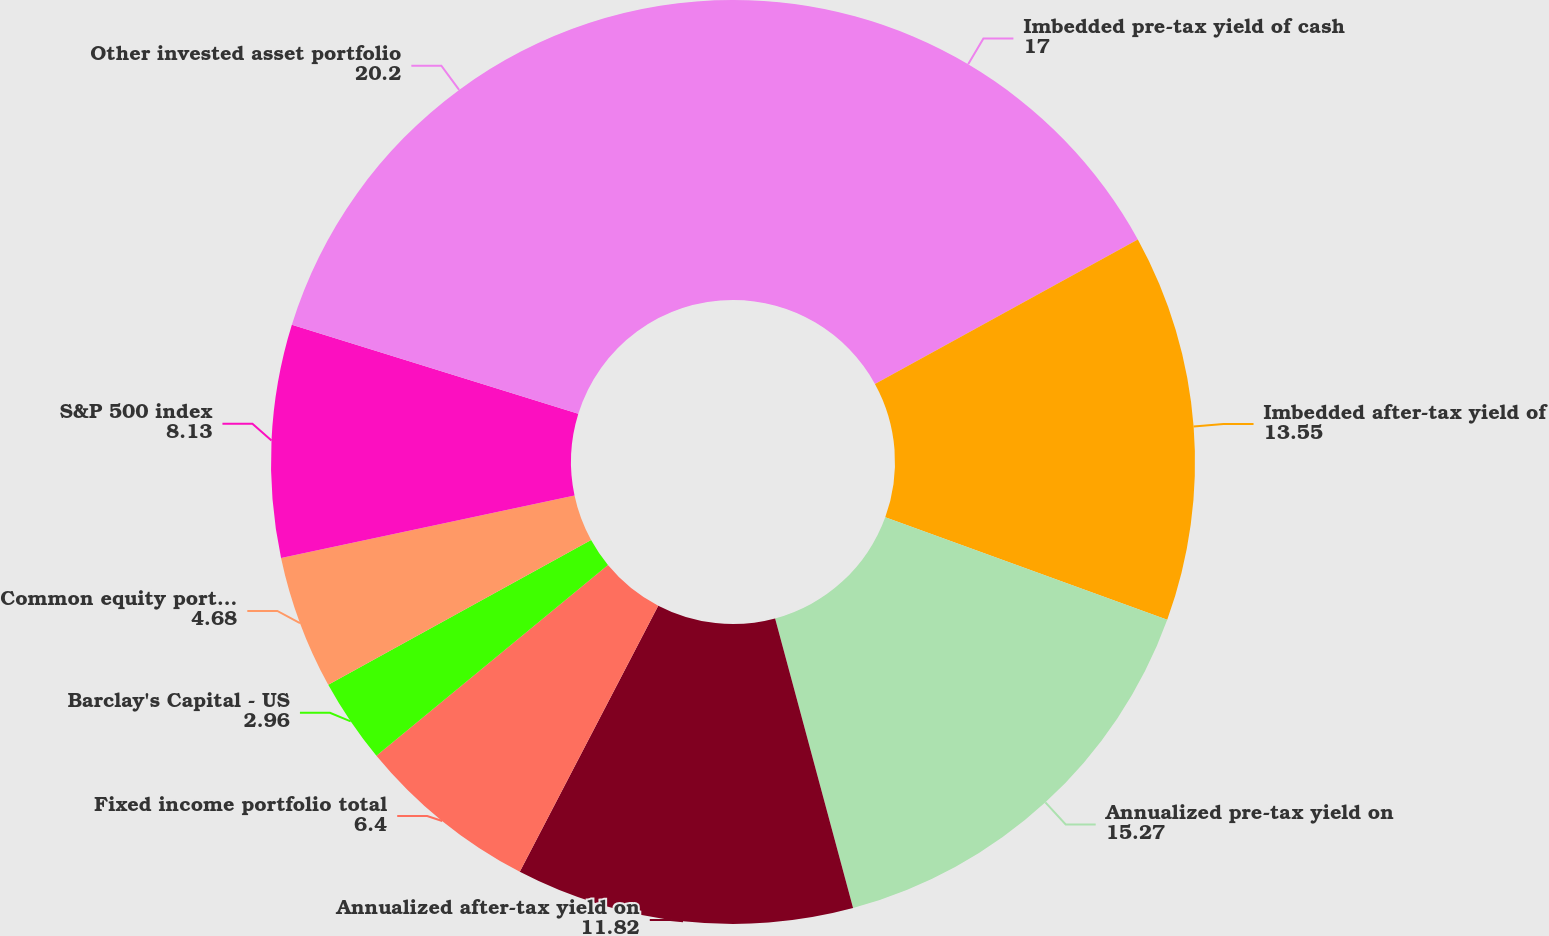<chart> <loc_0><loc_0><loc_500><loc_500><pie_chart><fcel>Imbedded pre-tax yield of cash<fcel>Imbedded after-tax yield of<fcel>Annualized pre-tax yield on<fcel>Annualized after-tax yield on<fcel>Fixed income portfolio total<fcel>Barclay's Capital - US<fcel>Common equity portfolio total<fcel>S&P 500 index<fcel>Other invested asset portfolio<nl><fcel>17.0%<fcel>13.55%<fcel>15.27%<fcel>11.82%<fcel>6.4%<fcel>2.96%<fcel>4.68%<fcel>8.13%<fcel>20.2%<nl></chart> 